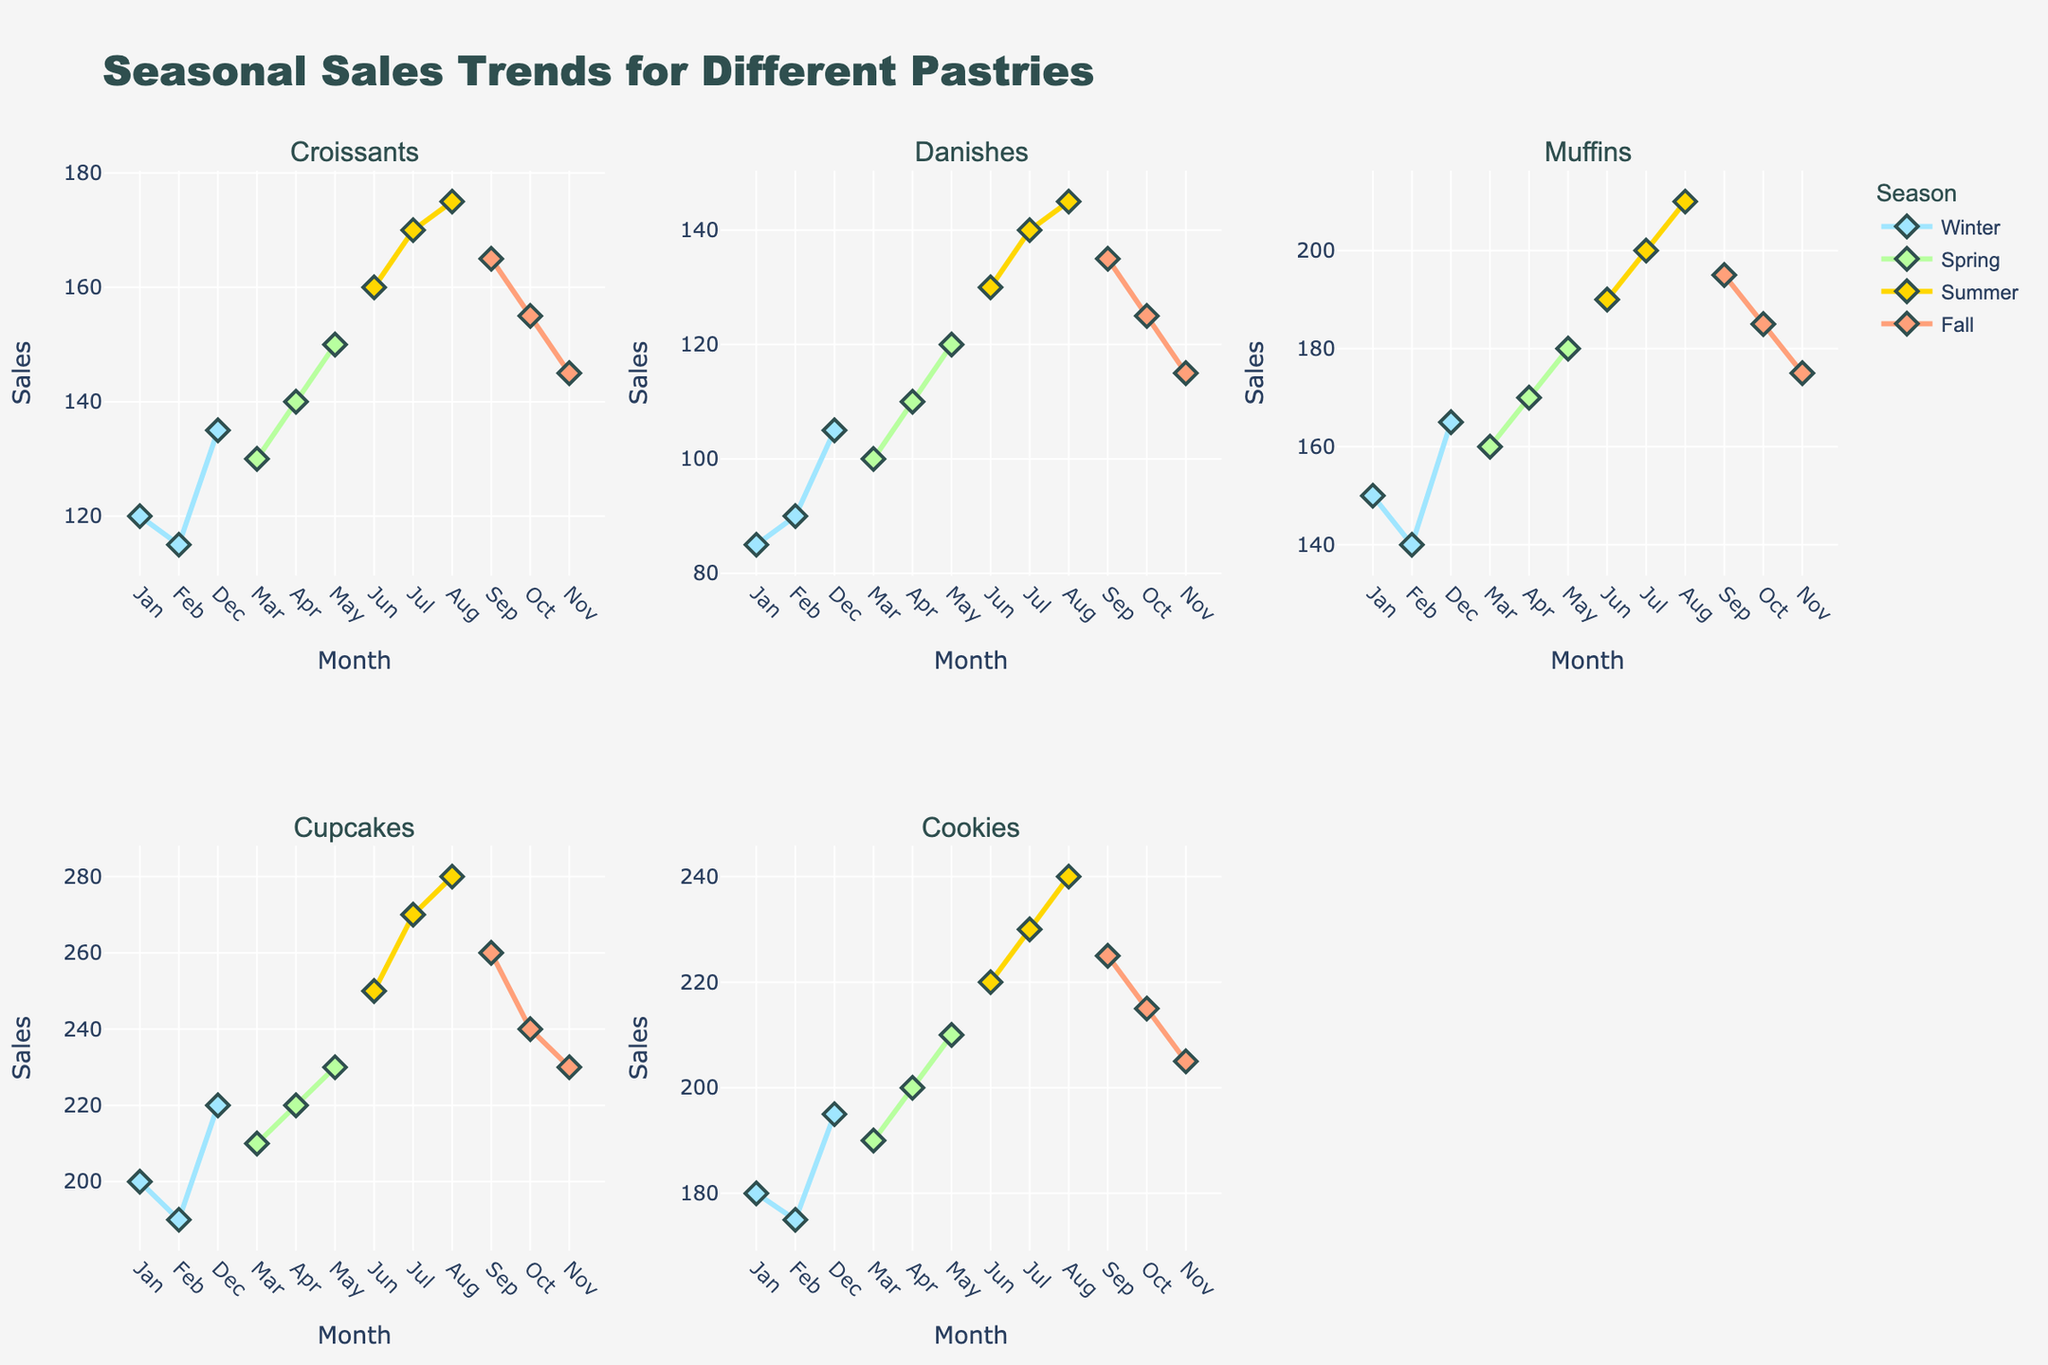What's the title of the figure? The title is displayed at the top of the figure in larger and bold font, making it easy to identify.
Answer: Seasonal Sales Trends for Different Pastries What are the sales numbers for Croissants in January and July? To find the sales numbers, look at the scatterplot for Croissants and identify the data points corresponding to January and July.
Answer: 120 and 170 Which season has the highest sales for Cookies? In the scatterplot for Cookies, the line representing the season with the highest endpoint indicates the highest sales.
Answer: Summer How many different pastry types are shown in the figure? The subplot titles list the different types of pastries. Count these titles.
Answer: 5 Which pastry shows the most noticeable seasonal variation in sales? Look at each scatterplot to identify which pastry has the biggest changes in sales points across different seasons.
Answer: Cupcakes Between Croissants and Muffins, which pastry has higher sales on average during Spring? Calculate the average sales for each pastry type by adding the sales numbers for each spring month and dividing by the number of months.
Answer: Muffins During which month do Cupcakes have the highest sales, and what is that number? Locate the highest point on the scatterplot for Cupcakes and note the corresponding month and sales figure.
Answer: August, 280 Compare the sales trend of Danishes in Winter and Summer. What do you observe? Identify and compare the trend lines for Winter and Summer in the Danishes scatterplot. Look at the slope, shape, and differences between data points.
Answer: Increasing in Summer, relatively stable in Winter What is the color associated with Fall in the plots? The legend provides the colors linked to each season. Identify Fall's color from there.
Answer: Orange Calculate the total sales of Muffins over the year. Add the sales numbers of Muffins for each month: 150 + 140 + 160 + 170 + 180 + 190 + 200 + 210 + 195 + 185 + 175 + 165 = 2220
Answer: 2220 